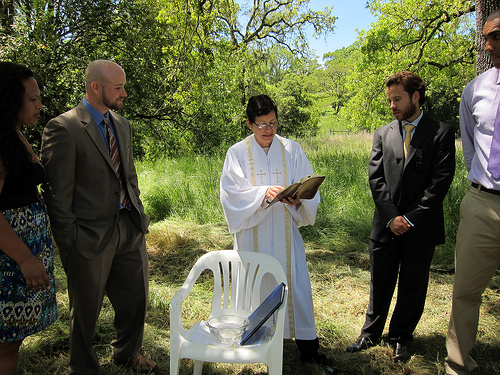<image>
Is the priest above the holy water? No. The priest is not positioned above the holy water. The vertical arrangement shows a different relationship. 